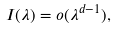Convert formula to latex. <formula><loc_0><loc_0><loc_500><loc_500>I ( \lambda ) = o ( \lambda ^ { d - 1 } ) ,</formula> 